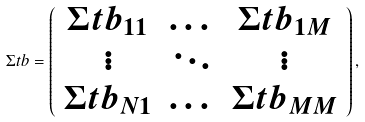Convert formula to latex. <formula><loc_0><loc_0><loc_500><loc_500>\Sigma t b = \left ( \begin{array} { c c c } \Sigma t b _ { 1 1 } & \dots & \Sigma t b _ { 1 M } \\ \vdots & \ddots & \vdots \\ \Sigma t b _ { N 1 } & \dots & \Sigma t b _ { M M } \\ \end{array} \right ) ,</formula> 